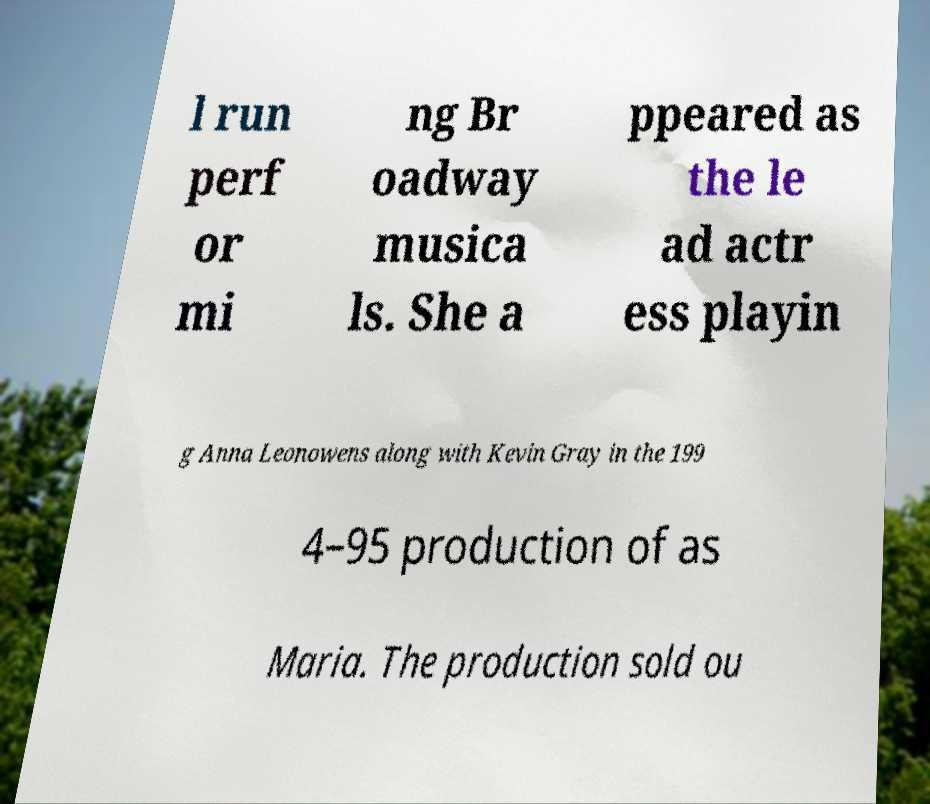Please identify and transcribe the text found in this image. l run perf or mi ng Br oadway musica ls. She a ppeared as the le ad actr ess playin g Anna Leonowens along with Kevin Gray in the 199 4–95 production of as Maria. The production sold ou 